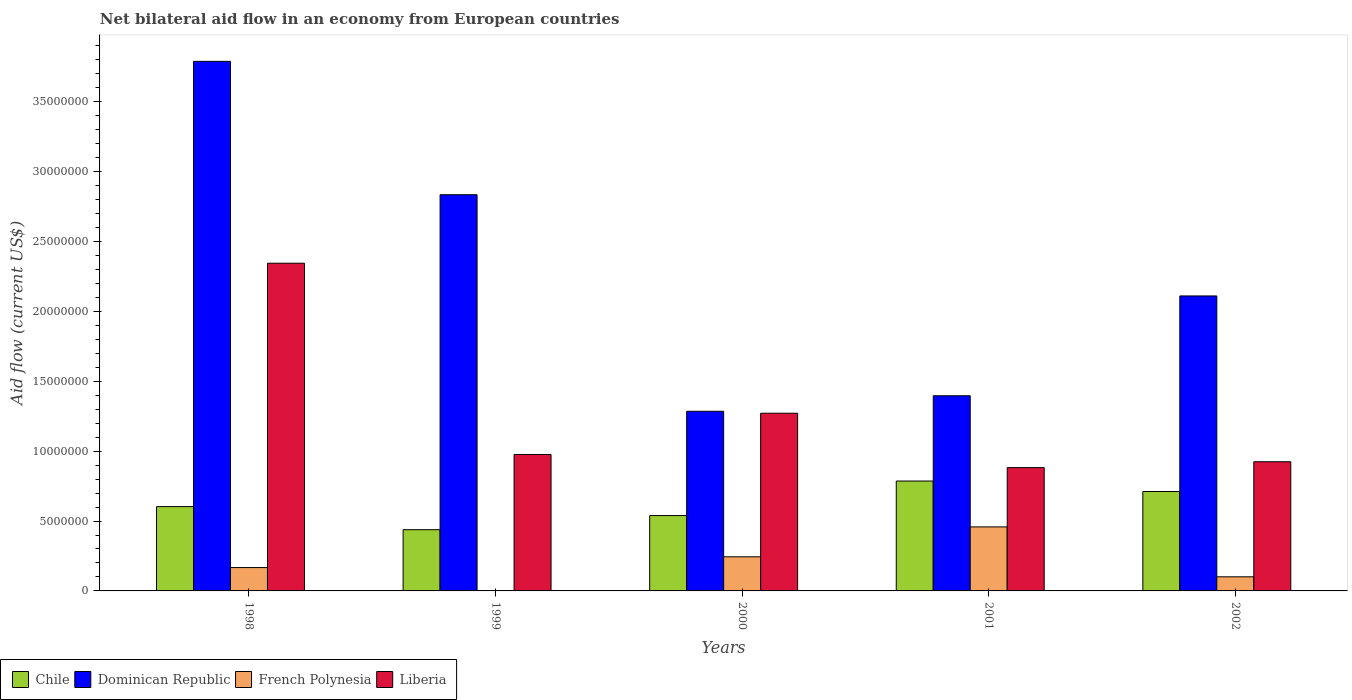Are the number of bars per tick equal to the number of legend labels?
Make the answer very short. No. How many bars are there on the 5th tick from the right?
Your answer should be compact. 4. What is the label of the 3rd group of bars from the left?
Give a very brief answer. 2000. What is the net bilateral aid flow in Liberia in 1999?
Provide a succinct answer. 9.76e+06. Across all years, what is the maximum net bilateral aid flow in Dominican Republic?
Give a very brief answer. 3.79e+07. Across all years, what is the minimum net bilateral aid flow in Liberia?
Provide a succinct answer. 8.82e+06. What is the total net bilateral aid flow in Liberia in the graph?
Offer a very short reply. 6.40e+07. What is the difference between the net bilateral aid flow in Dominican Republic in 1998 and that in 2001?
Keep it short and to the point. 2.39e+07. What is the difference between the net bilateral aid flow in Liberia in 2000 and the net bilateral aid flow in Dominican Republic in 1998?
Offer a terse response. -2.52e+07. What is the average net bilateral aid flow in Chile per year?
Your answer should be very brief. 6.15e+06. In the year 1998, what is the difference between the net bilateral aid flow in Liberia and net bilateral aid flow in French Polynesia?
Your answer should be very brief. 2.18e+07. In how many years, is the net bilateral aid flow in Chile greater than 37000000 US$?
Offer a terse response. 0. What is the ratio of the net bilateral aid flow in Chile in 1999 to that in 2001?
Give a very brief answer. 0.56. What is the difference between the highest and the second highest net bilateral aid flow in French Polynesia?
Make the answer very short. 2.14e+06. What is the difference between the highest and the lowest net bilateral aid flow in French Polynesia?
Ensure brevity in your answer.  4.58e+06. In how many years, is the net bilateral aid flow in Chile greater than the average net bilateral aid flow in Chile taken over all years?
Ensure brevity in your answer.  2. Are all the bars in the graph horizontal?
Ensure brevity in your answer.  No. How many years are there in the graph?
Your response must be concise. 5. What is the difference between two consecutive major ticks on the Y-axis?
Your answer should be very brief. 5.00e+06. Are the values on the major ticks of Y-axis written in scientific E-notation?
Your answer should be very brief. No. Does the graph contain any zero values?
Make the answer very short. Yes. Does the graph contain grids?
Make the answer very short. No. Where does the legend appear in the graph?
Your answer should be very brief. Bottom left. How many legend labels are there?
Offer a very short reply. 4. How are the legend labels stacked?
Your answer should be very brief. Horizontal. What is the title of the graph?
Your answer should be very brief. Net bilateral aid flow in an economy from European countries. What is the label or title of the X-axis?
Keep it short and to the point. Years. What is the Aid flow (current US$) in Chile in 1998?
Offer a very short reply. 6.03e+06. What is the Aid flow (current US$) of Dominican Republic in 1998?
Your answer should be compact. 3.79e+07. What is the Aid flow (current US$) of French Polynesia in 1998?
Your answer should be very brief. 1.67e+06. What is the Aid flow (current US$) of Liberia in 1998?
Ensure brevity in your answer.  2.34e+07. What is the Aid flow (current US$) in Chile in 1999?
Provide a succinct answer. 4.38e+06. What is the Aid flow (current US$) of Dominican Republic in 1999?
Offer a very short reply. 2.83e+07. What is the Aid flow (current US$) in Liberia in 1999?
Offer a terse response. 9.76e+06. What is the Aid flow (current US$) of Chile in 2000?
Offer a terse response. 5.39e+06. What is the Aid flow (current US$) of Dominican Republic in 2000?
Make the answer very short. 1.28e+07. What is the Aid flow (current US$) in French Polynesia in 2000?
Ensure brevity in your answer.  2.44e+06. What is the Aid flow (current US$) in Liberia in 2000?
Your response must be concise. 1.27e+07. What is the Aid flow (current US$) in Chile in 2001?
Your answer should be very brief. 7.86e+06. What is the Aid flow (current US$) in Dominican Republic in 2001?
Offer a terse response. 1.40e+07. What is the Aid flow (current US$) of French Polynesia in 2001?
Make the answer very short. 4.58e+06. What is the Aid flow (current US$) of Liberia in 2001?
Ensure brevity in your answer.  8.82e+06. What is the Aid flow (current US$) of Chile in 2002?
Your answer should be compact. 7.11e+06. What is the Aid flow (current US$) of Dominican Republic in 2002?
Offer a terse response. 2.11e+07. What is the Aid flow (current US$) of French Polynesia in 2002?
Your answer should be compact. 1.01e+06. What is the Aid flow (current US$) of Liberia in 2002?
Your answer should be compact. 9.24e+06. Across all years, what is the maximum Aid flow (current US$) in Chile?
Provide a short and direct response. 7.86e+06. Across all years, what is the maximum Aid flow (current US$) in Dominican Republic?
Offer a very short reply. 3.79e+07. Across all years, what is the maximum Aid flow (current US$) of French Polynesia?
Provide a short and direct response. 4.58e+06. Across all years, what is the maximum Aid flow (current US$) of Liberia?
Your answer should be compact. 2.34e+07. Across all years, what is the minimum Aid flow (current US$) in Chile?
Your answer should be very brief. 4.38e+06. Across all years, what is the minimum Aid flow (current US$) in Dominican Republic?
Offer a terse response. 1.28e+07. Across all years, what is the minimum Aid flow (current US$) in Liberia?
Give a very brief answer. 8.82e+06. What is the total Aid flow (current US$) of Chile in the graph?
Give a very brief answer. 3.08e+07. What is the total Aid flow (current US$) of Dominican Republic in the graph?
Your response must be concise. 1.14e+08. What is the total Aid flow (current US$) in French Polynesia in the graph?
Offer a very short reply. 9.70e+06. What is the total Aid flow (current US$) in Liberia in the graph?
Offer a terse response. 6.40e+07. What is the difference between the Aid flow (current US$) in Chile in 1998 and that in 1999?
Provide a short and direct response. 1.65e+06. What is the difference between the Aid flow (current US$) in Dominican Republic in 1998 and that in 1999?
Keep it short and to the point. 9.54e+06. What is the difference between the Aid flow (current US$) in Liberia in 1998 and that in 1999?
Your answer should be compact. 1.37e+07. What is the difference between the Aid flow (current US$) in Chile in 1998 and that in 2000?
Offer a terse response. 6.40e+05. What is the difference between the Aid flow (current US$) of Dominican Republic in 1998 and that in 2000?
Provide a succinct answer. 2.50e+07. What is the difference between the Aid flow (current US$) in French Polynesia in 1998 and that in 2000?
Provide a short and direct response. -7.70e+05. What is the difference between the Aid flow (current US$) of Liberia in 1998 and that in 2000?
Make the answer very short. 1.07e+07. What is the difference between the Aid flow (current US$) of Chile in 1998 and that in 2001?
Your response must be concise. -1.83e+06. What is the difference between the Aid flow (current US$) in Dominican Republic in 1998 and that in 2001?
Offer a terse response. 2.39e+07. What is the difference between the Aid flow (current US$) in French Polynesia in 1998 and that in 2001?
Keep it short and to the point. -2.91e+06. What is the difference between the Aid flow (current US$) of Liberia in 1998 and that in 2001?
Provide a succinct answer. 1.46e+07. What is the difference between the Aid flow (current US$) in Chile in 1998 and that in 2002?
Offer a terse response. -1.08e+06. What is the difference between the Aid flow (current US$) of Dominican Republic in 1998 and that in 2002?
Ensure brevity in your answer.  1.68e+07. What is the difference between the Aid flow (current US$) in French Polynesia in 1998 and that in 2002?
Offer a terse response. 6.60e+05. What is the difference between the Aid flow (current US$) of Liberia in 1998 and that in 2002?
Provide a short and direct response. 1.42e+07. What is the difference between the Aid flow (current US$) in Chile in 1999 and that in 2000?
Ensure brevity in your answer.  -1.01e+06. What is the difference between the Aid flow (current US$) of Dominican Republic in 1999 and that in 2000?
Offer a very short reply. 1.55e+07. What is the difference between the Aid flow (current US$) in Liberia in 1999 and that in 2000?
Ensure brevity in your answer.  -2.95e+06. What is the difference between the Aid flow (current US$) in Chile in 1999 and that in 2001?
Provide a succinct answer. -3.48e+06. What is the difference between the Aid flow (current US$) in Dominican Republic in 1999 and that in 2001?
Provide a short and direct response. 1.44e+07. What is the difference between the Aid flow (current US$) in Liberia in 1999 and that in 2001?
Make the answer very short. 9.40e+05. What is the difference between the Aid flow (current US$) in Chile in 1999 and that in 2002?
Your response must be concise. -2.73e+06. What is the difference between the Aid flow (current US$) of Dominican Republic in 1999 and that in 2002?
Give a very brief answer. 7.24e+06. What is the difference between the Aid flow (current US$) in Liberia in 1999 and that in 2002?
Offer a terse response. 5.20e+05. What is the difference between the Aid flow (current US$) of Chile in 2000 and that in 2001?
Make the answer very short. -2.47e+06. What is the difference between the Aid flow (current US$) in Dominican Republic in 2000 and that in 2001?
Your response must be concise. -1.11e+06. What is the difference between the Aid flow (current US$) of French Polynesia in 2000 and that in 2001?
Offer a terse response. -2.14e+06. What is the difference between the Aid flow (current US$) in Liberia in 2000 and that in 2001?
Provide a short and direct response. 3.89e+06. What is the difference between the Aid flow (current US$) in Chile in 2000 and that in 2002?
Provide a short and direct response. -1.72e+06. What is the difference between the Aid flow (current US$) of Dominican Republic in 2000 and that in 2002?
Ensure brevity in your answer.  -8.25e+06. What is the difference between the Aid flow (current US$) in French Polynesia in 2000 and that in 2002?
Your response must be concise. 1.43e+06. What is the difference between the Aid flow (current US$) in Liberia in 2000 and that in 2002?
Offer a very short reply. 3.47e+06. What is the difference between the Aid flow (current US$) in Chile in 2001 and that in 2002?
Offer a terse response. 7.50e+05. What is the difference between the Aid flow (current US$) in Dominican Republic in 2001 and that in 2002?
Provide a short and direct response. -7.14e+06. What is the difference between the Aid flow (current US$) in French Polynesia in 2001 and that in 2002?
Your answer should be compact. 3.57e+06. What is the difference between the Aid flow (current US$) of Liberia in 2001 and that in 2002?
Offer a terse response. -4.20e+05. What is the difference between the Aid flow (current US$) of Chile in 1998 and the Aid flow (current US$) of Dominican Republic in 1999?
Keep it short and to the point. -2.23e+07. What is the difference between the Aid flow (current US$) of Chile in 1998 and the Aid flow (current US$) of Liberia in 1999?
Your response must be concise. -3.73e+06. What is the difference between the Aid flow (current US$) of Dominican Republic in 1998 and the Aid flow (current US$) of Liberia in 1999?
Your response must be concise. 2.81e+07. What is the difference between the Aid flow (current US$) in French Polynesia in 1998 and the Aid flow (current US$) in Liberia in 1999?
Your answer should be very brief. -8.09e+06. What is the difference between the Aid flow (current US$) of Chile in 1998 and the Aid flow (current US$) of Dominican Republic in 2000?
Offer a terse response. -6.82e+06. What is the difference between the Aid flow (current US$) in Chile in 1998 and the Aid flow (current US$) in French Polynesia in 2000?
Ensure brevity in your answer.  3.59e+06. What is the difference between the Aid flow (current US$) of Chile in 1998 and the Aid flow (current US$) of Liberia in 2000?
Ensure brevity in your answer.  -6.68e+06. What is the difference between the Aid flow (current US$) in Dominican Republic in 1998 and the Aid flow (current US$) in French Polynesia in 2000?
Offer a terse response. 3.54e+07. What is the difference between the Aid flow (current US$) of Dominican Republic in 1998 and the Aid flow (current US$) of Liberia in 2000?
Your response must be concise. 2.52e+07. What is the difference between the Aid flow (current US$) in French Polynesia in 1998 and the Aid flow (current US$) in Liberia in 2000?
Make the answer very short. -1.10e+07. What is the difference between the Aid flow (current US$) of Chile in 1998 and the Aid flow (current US$) of Dominican Republic in 2001?
Your response must be concise. -7.93e+06. What is the difference between the Aid flow (current US$) of Chile in 1998 and the Aid flow (current US$) of French Polynesia in 2001?
Your response must be concise. 1.45e+06. What is the difference between the Aid flow (current US$) of Chile in 1998 and the Aid flow (current US$) of Liberia in 2001?
Make the answer very short. -2.79e+06. What is the difference between the Aid flow (current US$) of Dominican Republic in 1998 and the Aid flow (current US$) of French Polynesia in 2001?
Provide a short and direct response. 3.33e+07. What is the difference between the Aid flow (current US$) in Dominican Republic in 1998 and the Aid flow (current US$) in Liberia in 2001?
Offer a terse response. 2.91e+07. What is the difference between the Aid flow (current US$) in French Polynesia in 1998 and the Aid flow (current US$) in Liberia in 2001?
Your answer should be compact. -7.15e+06. What is the difference between the Aid flow (current US$) in Chile in 1998 and the Aid flow (current US$) in Dominican Republic in 2002?
Give a very brief answer. -1.51e+07. What is the difference between the Aid flow (current US$) of Chile in 1998 and the Aid flow (current US$) of French Polynesia in 2002?
Provide a succinct answer. 5.02e+06. What is the difference between the Aid flow (current US$) of Chile in 1998 and the Aid flow (current US$) of Liberia in 2002?
Ensure brevity in your answer.  -3.21e+06. What is the difference between the Aid flow (current US$) in Dominican Republic in 1998 and the Aid flow (current US$) in French Polynesia in 2002?
Offer a terse response. 3.69e+07. What is the difference between the Aid flow (current US$) of Dominican Republic in 1998 and the Aid flow (current US$) of Liberia in 2002?
Your response must be concise. 2.86e+07. What is the difference between the Aid flow (current US$) of French Polynesia in 1998 and the Aid flow (current US$) of Liberia in 2002?
Keep it short and to the point. -7.57e+06. What is the difference between the Aid flow (current US$) of Chile in 1999 and the Aid flow (current US$) of Dominican Republic in 2000?
Your response must be concise. -8.47e+06. What is the difference between the Aid flow (current US$) in Chile in 1999 and the Aid flow (current US$) in French Polynesia in 2000?
Offer a very short reply. 1.94e+06. What is the difference between the Aid flow (current US$) of Chile in 1999 and the Aid flow (current US$) of Liberia in 2000?
Offer a very short reply. -8.33e+06. What is the difference between the Aid flow (current US$) of Dominican Republic in 1999 and the Aid flow (current US$) of French Polynesia in 2000?
Provide a succinct answer. 2.59e+07. What is the difference between the Aid flow (current US$) of Dominican Republic in 1999 and the Aid flow (current US$) of Liberia in 2000?
Provide a succinct answer. 1.56e+07. What is the difference between the Aid flow (current US$) in Chile in 1999 and the Aid flow (current US$) in Dominican Republic in 2001?
Your answer should be compact. -9.58e+06. What is the difference between the Aid flow (current US$) in Chile in 1999 and the Aid flow (current US$) in Liberia in 2001?
Provide a succinct answer. -4.44e+06. What is the difference between the Aid flow (current US$) of Dominican Republic in 1999 and the Aid flow (current US$) of French Polynesia in 2001?
Offer a very short reply. 2.38e+07. What is the difference between the Aid flow (current US$) of Dominican Republic in 1999 and the Aid flow (current US$) of Liberia in 2001?
Keep it short and to the point. 1.95e+07. What is the difference between the Aid flow (current US$) in Chile in 1999 and the Aid flow (current US$) in Dominican Republic in 2002?
Give a very brief answer. -1.67e+07. What is the difference between the Aid flow (current US$) of Chile in 1999 and the Aid flow (current US$) of French Polynesia in 2002?
Provide a short and direct response. 3.37e+06. What is the difference between the Aid flow (current US$) of Chile in 1999 and the Aid flow (current US$) of Liberia in 2002?
Your answer should be compact. -4.86e+06. What is the difference between the Aid flow (current US$) of Dominican Republic in 1999 and the Aid flow (current US$) of French Polynesia in 2002?
Provide a succinct answer. 2.73e+07. What is the difference between the Aid flow (current US$) in Dominican Republic in 1999 and the Aid flow (current US$) in Liberia in 2002?
Your response must be concise. 1.91e+07. What is the difference between the Aid flow (current US$) of Chile in 2000 and the Aid flow (current US$) of Dominican Republic in 2001?
Ensure brevity in your answer.  -8.57e+06. What is the difference between the Aid flow (current US$) in Chile in 2000 and the Aid flow (current US$) in French Polynesia in 2001?
Offer a very short reply. 8.10e+05. What is the difference between the Aid flow (current US$) in Chile in 2000 and the Aid flow (current US$) in Liberia in 2001?
Offer a very short reply. -3.43e+06. What is the difference between the Aid flow (current US$) in Dominican Republic in 2000 and the Aid flow (current US$) in French Polynesia in 2001?
Offer a very short reply. 8.27e+06. What is the difference between the Aid flow (current US$) of Dominican Republic in 2000 and the Aid flow (current US$) of Liberia in 2001?
Your response must be concise. 4.03e+06. What is the difference between the Aid flow (current US$) of French Polynesia in 2000 and the Aid flow (current US$) of Liberia in 2001?
Your answer should be very brief. -6.38e+06. What is the difference between the Aid flow (current US$) in Chile in 2000 and the Aid flow (current US$) in Dominican Republic in 2002?
Keep it short and to the point. -1.57e+07. What is the difference between the Aid flow (current US$) in Chile in 2000 and the Aid flow (current US$) in French Polynesia in 2002?
Your answer should be compact. 4.38e+06. What is the difference between the Aid flow (current US$) of Chile in 2000 and the Aid flow (current US$) of Liberia in 2002?
Give a very brief answer. -3.85e+06. What is the difference between the Aid flow (current US$) in Dominican Republic in 2000 and the Aid flow (current US$) in French Polynesia in 2002?
Your answer should be very brief. 1.18e+07. What is the difference between the Aid flow (current US$) of Dominican Republic in 2000 and the Aid flow (current US$) of Liberia in 2002?
Offer a very short reply. 3.61e+06. What is the difference between the Aid flow (current US$) in French Polynesia in 2000 and the Aid flow (current US$) in Liberia in 2002?
Offer a terse response. -6.80e+06. What is the difference between the Aid flow (current US$) of Chile in 2001 and the Aid flow (current US$) of Dominican Republic in 2002?
Offer a very short reply. -1.32e+07. What is the difference between the Aid flow (current US$) in Chile in 2001 and the Aid flow (current US$) in French Polynesia in 2002?
Provide a succinct answer. 6.85e+06. What is the difference between the Aid flow (current US$) of Chile in 2001 and the Aid flow (current US$) of Liberia in 2002?
Provide a succinct answer. -1.38e+06. What is the difference between the Aid flow (current US$) of Dominican Republic in 2001 and the Aid flow (current US$) of French Polynesia in 2002?
Ensure brevity in your answer.  1.30e+07. What is the difference between the Aid flow (current US$) of Dominican Republic in 2001 and the Aid flow (current US$) of Liberia in 2002?
Provide a short and direct response. 4.72e+06. What is the difference between the Aid flow (current US$) in French Polynesia in 2001 and the Aid flow (current US$) in Liberia in 2002?
Make the answer very short. -4.66e+06. What is the average Aid flow (current US$) in Chile per year?
Give a very brief answer. 6.15e+06. What is the average Aid flow (current US$) of Dominican Republic per year?
Offer a terse response. 2.28e+07. What is the average Aid flow (current US$) in French Polynesia per year?
Ensure brevity in your answer.  1.94e+06. What is the average Aid flow (current US$) in Liberia per year?
Your response must be concise. 1.28e+07. In the year 1998, what is the difference between the Aid flow (current US$) in Chile and Aid flow (current US$) in Dominican Republic?
Your answer should be compact. -3.18e+07. In the year 1998, what is the difference between the Aid flow (current US$) in Chile and Aid flow (current US$) in French Polynesia?
Provide a succinct answer. 4.36e+06. In the year 1998, what is the difference between the Aid flow (current US$) of Chile and Aid flow (current US$) of Liberia?
Make the answer very short. -1.74e+07. In the year 1998, what is the difference between the Aid flow (current US$) of Dominican Republic and Aid flow (current US$) of French Polynesia?
Offer a very short reply. 3.62e+07. In the year 1998, what is the difference between the Aid flow (current US$) of Dominican Republic and Aid flow (current US$) of Liberia?
Offer a very short reply. 1.44e+07. In the year 1998, what is the difference between the Aid flow (current US$) in French Polynesia and Aid flow (current US$) in Liberia?
Make the answer very short. -2.18e+07. In the year 1999, what is the difference between the Aid flow (current US$) of Chile and Aid flow (current US$) of Dominican Republic?
Ensure brevity in your answer.  -2.40e+07. In the year 1999, what is the difference between the Aid flow (current US$) of Chile and Aid flow (current US$) of Liberia?
Keep it short and to the point. -5.38e+06. In the year 1999, what is the difference between the Aid flow (current US$) in Dominican Republic and Aid flow (current US$) in Liberia?
Give a very brief answer. 1.86e+07. In the year 2000, what is the difference between the Aid flow (current US$) in Chile and Aid flow (current US$) in Dominican Republic?
Offer a very short reply. -7.46e+06. In the year 2000, what is the difference between the Aid flow (current US$) of Chile and Aid flow (current US$) of French Polynesia?
Your answer should be very brief. 2.95e+06. In the year 2000, what is the difference between the Aid flow (current US$) of Chile and Aid flow (current US$) of Liberia?
Your answer should be very brief. -7.32e+06. In the year 2000, what is the difference between the Aid flow (current US$) of Dominican Republic and Aid flow (current US$) of French Polynesia?
Provide a short and direct response. 1.04e+07. In the year 2000, what is the difference between the Aid flow (current US$) in French Polynesia and Aid flow (current US$) in Liberia?
Ensure brevity in your answer.  -1.03e+07. In the year 2001, what is the difference between the Aid flow (current US$) in Chile and Aid flow (current US$) in Dominican Republic?
Your answer should be very brief. -6.10e+06. In the year 2001, what is the difference between the Aid flow (current US$) in Chile and Aid flow (current US$) in French Polynesia?
Your response must be concise. 3.28e+06. In the year 2001, what is the difference between the Aid flow (current US$) in Chile and Aid flow (current US$) in Liberia?
Provide a succinct answer. -9.60e+05. In the year 2001, what is the difference between the Aid flow (current US$) in Dominican Republic and Aid flow (current US$) in French Polynesia?
Ensure brevity in your answer.  9.38e+06. In the year 2001, what is the difference between the Aid flow (current US$) of Dominican Republic and Aid flow (current US$) of Liberia?
Your answer should be compact. 5.14e+06. In the year 2001, what is the difference between the Aid flow (current US$) of French Polynesia and Aid flow (current US$) of Liberia?
Ensure brevity in your answer.  -4.24e+06. In the year 2002, what is the difference between the Aid flow (current US$) in Chile and Aid flow (current US$) in Dominican Republic?
Give a very brief answer. -1.40e+07. In the year 2002, what is the difference between the Aid flow (current US$) in Chile and Aid flow (current US$) in French Polynesia?
Ensure brevity in your answer.  6.10e+06. In the year 2002, what is the difference between the Aid flow (current US$) in Chile and Aid flow (current US$) in Liberia?
Provide a short and direct response. -2.13e+06. In the year 2002, what is the difference between the Aid flow (current US$) of Dominican Republic and Aid flow (current US$) of French Polynesia?
Make the answer very short. 2.01e+07. In the year 2002, what is the difference between the Aid flow (current US$) of Dominican Republic and Aid flow (current US$) of Liberia?
Your response must be concise. 1.19e+07. In the year 2002, what is the difference between the Aid flow (current US$) in French Polynesia and Aid flow (current US$) in Liberia?
Ensure brevity in your answer.  -8.23e+06. What is the ratio of the Aid flow (current US$) in Chile in 1998 to that in 1999?
Keep it short and to the point. 1.38. What is the ratio of the Aid flow (current US$) of Dominican Republic in 1998 to that in 1999?
Ensure brevity in your answer.  1.34. What is the ratio of the Aid flow (current US$) in Liberia in 1998 to that in 1999?
Keep it short and to the point. 2.4. What is the ratio of the Aid flow (current US$) in Chile in 1998 to that in 2000?
Your response must be concise. 1.12. What is the ratio of the Aid flow (current US$) of Dominican Republic in 1998 to that in 2000?
Keep it short and to the point. 2.95. What is the ratio of the Aid flow (current US$) in French Polynesia in 1998 to that in 2000?
Make the answer very short. 0.68. What is the ratio of the Aid flow (current US$) in Liberia in 1998 to that in 2000?
Your response must be concise. 1.84. What is the ratio of the Aid flow (current US$) of Chile in 1998 to that in 2001?
Make the answer very short. 0.77. What is the ratio of the Aid flow (current US$) of Dominican Republic in 1998 to that in 2001?
Offer a terse response. 2.71. What is the ratio of the Aid flow (current US$) in French Polynesia in 1998 to that in 2001?
Provide a succinct answer. 0.36. What is the ratio of the Aid flow (current US$) of Liberia in 1998 to that in 2001?
Make the answer very short. 2.66. What is the ratio of the Aid flow (current US$) in Chile in 1998 to that in 2002?
Your response must be concise. 0.85. What is the ratio of the Aid flow (current US$) of Dominican Republic in 1998 to that in 2002?
Give a very brief answer. 1.8. What is the ratio of the Aid flow (current US$) in French Polynesia in 1998 to that in 2002?
Offer a very short reply. 1.65. What is the ratio of the Aid flow (current US$) in Liberia in 1998 to that in 2002?
Provide a succinct answer. 2.54. What is the ratio of the Aid flow (current US$) of Chile in 1999 to that in 2000?
Your response must be concise. 0.81. What is the ratio of the Aid flow (current US$) of Dominican Republic in 1999 to that in 2000?
Your response must be concise. 2.21. What is the ratio of the Aid flow (current US$) in Liberia in 1999 to that in 2000?
Provide a succinct answer. 0.77. What is the ratio of the Aid flow (current US$) of Chile in 1999 to that in 2001?
Your answer should be compact. 0.56. What is the ratio of the Aid flow (current US$) of Dominican Republic in 1999 to that in 2001?
Ensure brevity in your answer.  2.03. What is the ratio of the Aid flow (current US$) of Liberia in 1999 to that in 2001?
Provide a short and direct response. 1.11. What is the ratio of the Aid flow (current US$) of Chile in 1999 to that in 2002?
Your response must be concise. 0.62. What is the ratio of the Aid flow (current US$) in Dominican Republic in 1999 to that in 2002?
Give a very brief answer. 1.34. What is the ratio of the Aid flow (current US$) in Liberia in 1999 to that in 2002?
Offer a very short reply. 1.06. What is the ratio of the Aid flow (current US$) of Chile in 2000 to that in 2001?
Ensure brevity in your answer.  0.69. What is the ratio of the Aid flow (current US$) in Dominican Republic in 2000 to that in 2001?
Provide a short and direct response. 0.92. What is the ratio of the Aid flow (current US$) of French Polynesia in 2000 to that in 2001?
Make the answer very short. 0.53. What is the ratio of the Aid flow (current US$) in Liberia in 2000 to that in 2001?
Provide a succinct answer. 1.44. What is the ratio of the Aid flow (current US$) in Chile in 2000 to that in 2002?
Make the answer very short. 0.76. What is the ratio of the Aid flow (current US$) in Dominican Republic in 2000 to that in 2002?
Provide a short and direct response. 0.61. What is the ratio of the Aid flow (current US$) of French Polynesia in 2000 to that in 2002?
Give a very brief answer. 2.42. What is the ratio of the Aid flow (current US$) of Liberia in 2000 to that in 2002?
Provide a succinct answer. 1.38. What is the ratio of the Aid flow (current US$) of Chile in 2001 to that in 2002?
Offer a terse response. 1.11. What is the ratio of the Aid flow (current US$) in Dominican Republic in 2001 to that in 2002?
Provide a short and direct response. 0.66. What is the ratio of the Aid flow (current US$) of French Polynesia in 2001 to that in 2002?
Make the answer very short. 4.53. What is the ratio of the Aid flow (current US$) in Liberia in 2001 to that in 2002?
Offer a terse response. 0.95. What is the difference between the highest and the second highest Aid flow (current US$) of Chile?
Provide a short and direct response. 7.50e+05. What is the difference between the highest and the second highest Aid flow (current US$) in Dominican Republic?
Your answer should be compact. 9.54e+06. What is the difference between the highest and the second highest Aid flow (current US$) in French Polynesia?
Provide a succinct answer. 2.14e+06. What is the difference between the highest and the second highest Aid flow (current US$) in Liberia?
Provide a succinct answer. 1.07e+07. What is the difference between the highest and the lowest Aid flow (current US$) in Chile?
Your answer should be very brief. 3.48e+06. What is the difference between the highest and the lowest Aid flow (current US$) in Dominican Republic?
Your answer should be very brief. 2.50e+07. What is the difference between the highest and the lowest Aid flow (current US$) in French Polynesia?
Your response must be concise. 4.58e+06. What is the difference between the highest and the lowest Aid flow (current US$) in Liberia?
Your response must be concise. 1.46e+07. 